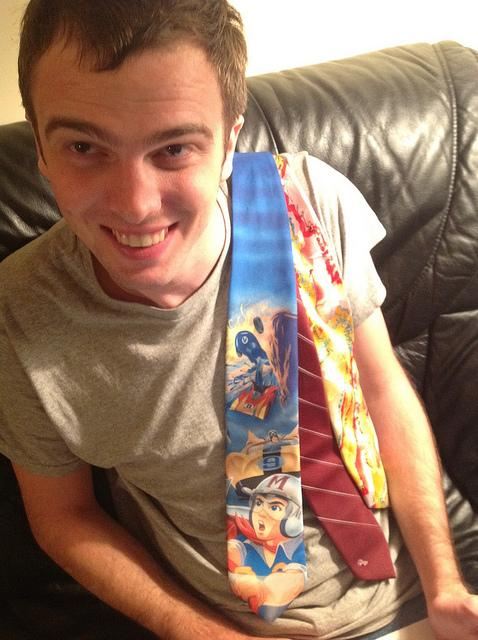What clothing item does the man have most of? Please explain your reasoning. ties. The man has a lot of ties on his shoulder. 